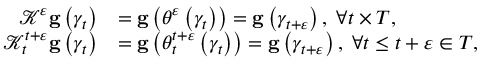<formula> <loc_0><loc_0><loc_500><loc_500>\begin{array} { r l } { \mathcal { K } ^ { \varepsilon } g \left ( \gamma _ { t } \right ) } & { = g \left ( \theta ^ { \varepsilon } \left ( \gamma _ { t } \right ) \right ) = g \left ( \gamma _ { t + \varepsilon } \right ) , \, \forall t \times T , } \\ { \mathcal { K } _ { t } ^ { t + \varepsilon } g \left ( \gamma _ { t } \right ) } & { = g \left ( \theta _ { t } ^ { t + \varepsilon } \left ( \gamma _ { t } \right ) \right ) = g \left ( \gamma _ { t + \varepsilon } \right ) , \, \forall t \leq t + \varepsilon \in T , } \end{array}</formula> 